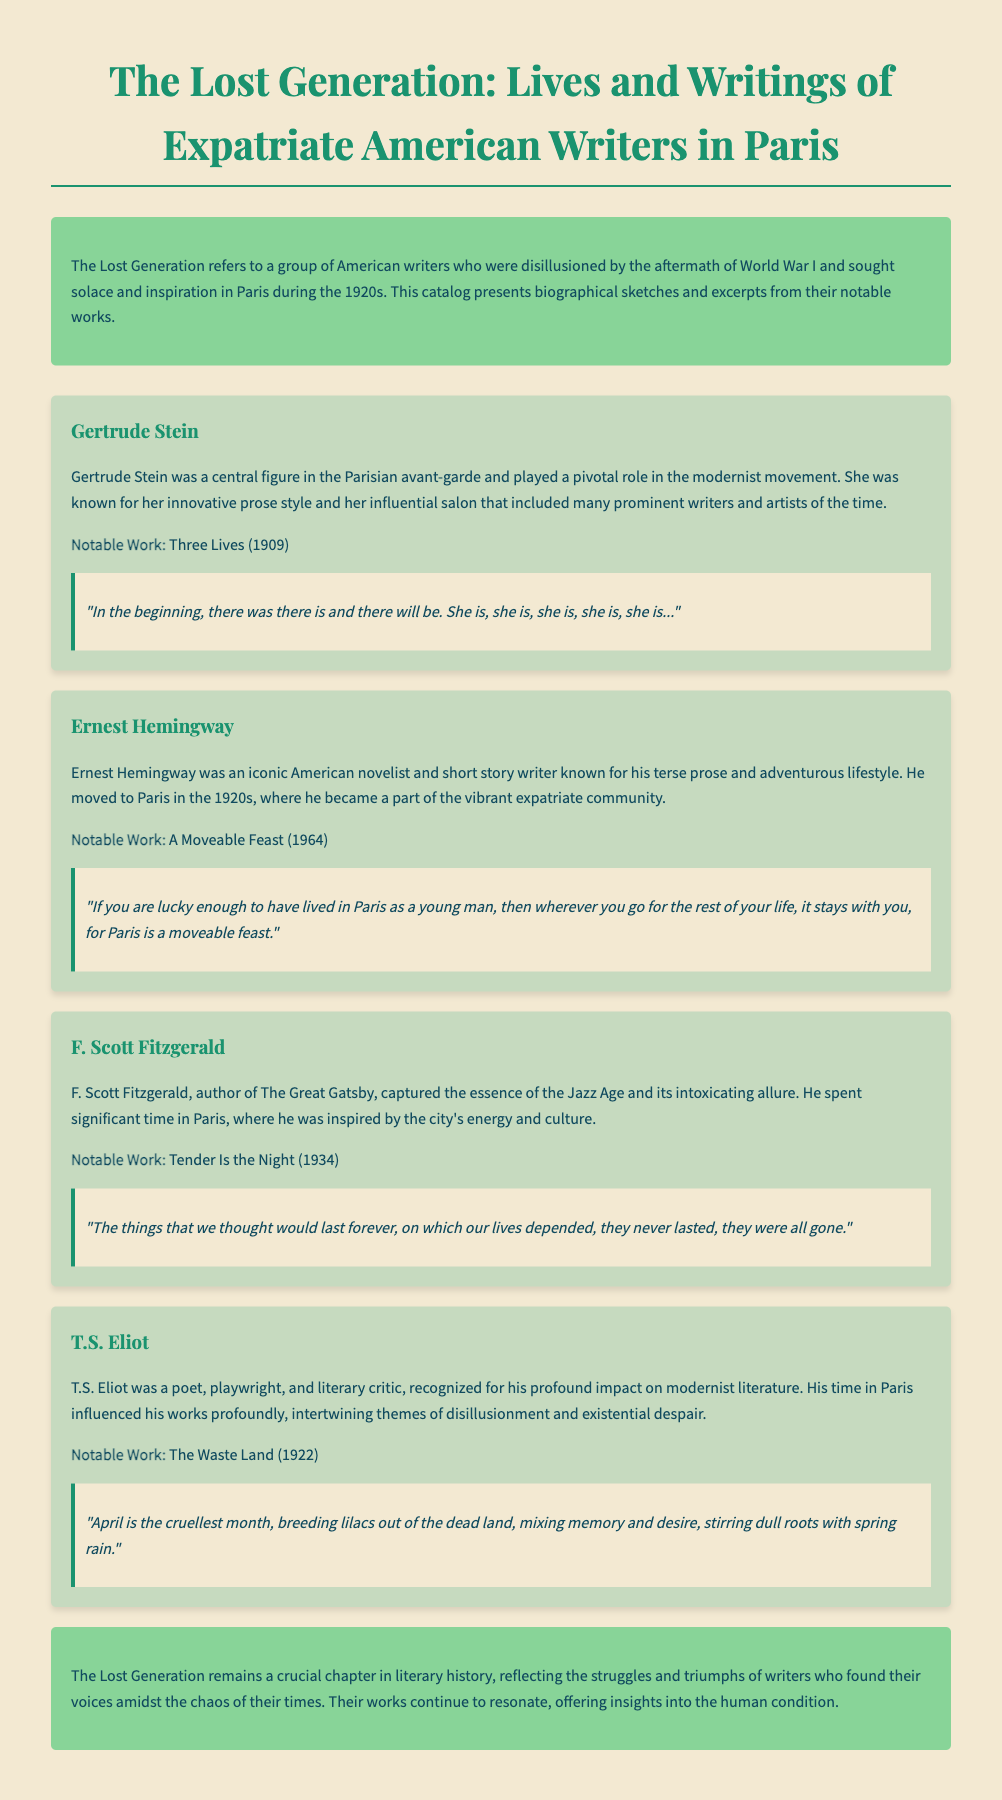What is the title of the document? The title is the main heading of the catalog, which is prominently displayed at the top.
Answer: The Lost Generation: Lives and Writings of Expatriate American Writers in Paris Who wrote "Three Lives"? The author of "Three Lives" is mentioned in the biographical section of the catalog.
Answer: Gertrude Stein In which year was "The Waste Land" published? The publication year of "The Waste Land" is explicitly stated alongside the noted work of T.S. Eliot.
Answer: 1922 What is the notable work of F. Scott Fitzgerald? F. Scott Fitzgerald's noted work is provided under his biographical section.
Answer: Tender Is the Night Which writer is associated with the phrase "a moveable feast"? The writer associated with this phrase is indicated in the excerpt from his notable work.
Answer: Ernest Hemingway What literary movement is Gertrude Stein associated with? The section describing her role highlights her influence on a specific literary movement.
Answer: Modernist movement What emotion is predominantly expressed in T.S. Eliot's work? The catalog discusses T.S. Eliot's themes, particularly relating to his experiences and influences.
Answer: Disillusionment How is the background color of the introductory section described? The style noted within the document elaborates on the aesthetics of the introductory content.
Answer: Background color is green 